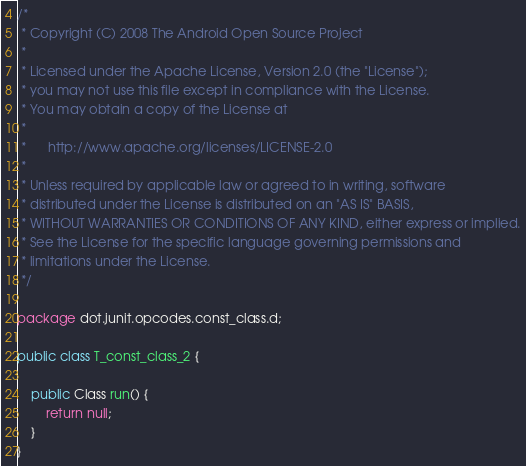Convert code to text. <code><loc_0><loc_0><loc_500><loc_500><_Java_>/*
 * Copyright (C) 2008 The Android Open Source Project
 *
 * Licensed under the Apache License, Version 2.0 (the "License");
 * you may not use this file except in compliance with the License.
 * You may obtain a copy of the License at
 *
 *      http://www.apache.org/licenses/LICENSE-2.0
 *
 * Unless required by applicable law or agreed to in writing, software
 * distributed under the License is distributed on an "AS IS" BASIS,
 * WITHOUT WARRANTIES OR CONDITIONS OF ANY KIND, either express or implied.
 * See the License for the specific language governing permissions and
 * limitations under the License.
 */

package dot.junit.opcodes.const_class.d;

public class T_const_class_2 {

    public Class run() {
        return null;
    }
}
</code> 